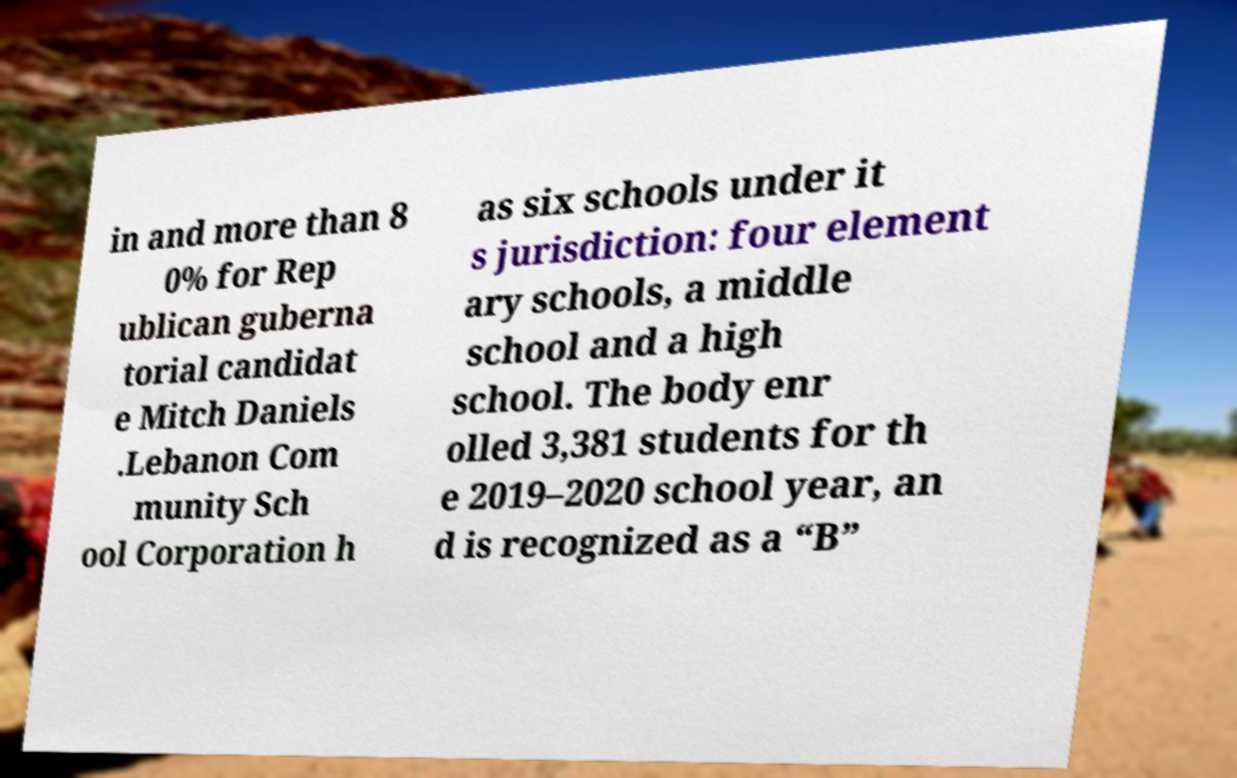Please identify and transcribe the text found in this image. in and more than 8 0% for Rep ublican guberna torial candidat e Mitch Daniels .Lebanon Com munity Sch ool Corporation h as six schools under it s jurisdiction: four element ary schools, a middle school and a high school. The body enr olled 3,381 students for th e 2019–2020 school year, an d is recognized as a “B” 